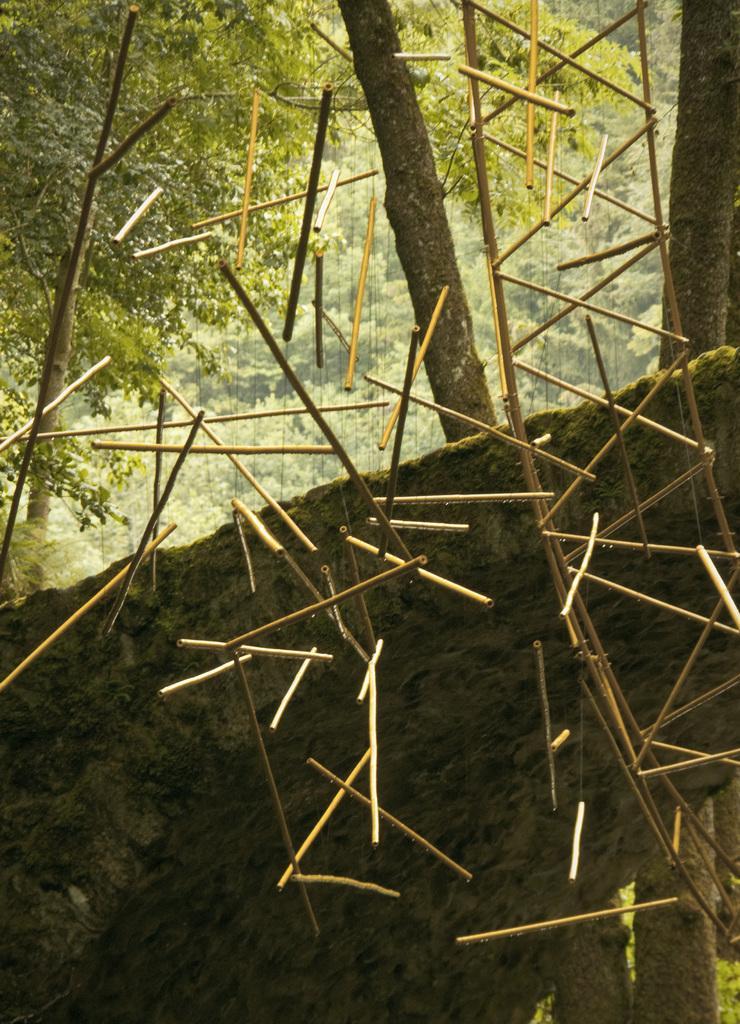Describe this image in one or two sentences. In this image I can see few sticks are hanging. Behind there is a rock. In the background there are many trees. 